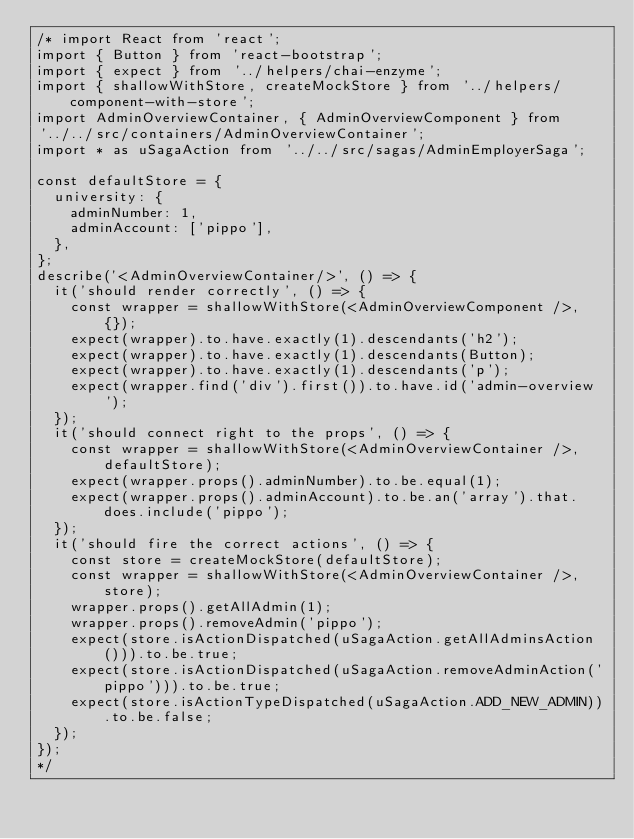Convert code to text. <code><loc_0><loc_0><loc_500><loc_500><_JavaScript_>/* import React from 'react';
import { Button } from 'react-bootstrap';
import { expect } from '../helpers/chai-enzyme';
import { shallowWithStore, createMockStore } from '../helpers/component-with-store';
import AdminOverviewContainer, { AdminOverviewComponent } from
'../../src/containers/AdminOverviewContainer';
import * as uSagaAction from '../../src/sagas/AdminEmployerSaga';

const defaultStore = {
  university: {
    adminNumber: 1,
    adminAccount: ['pippo'],
  },
};
describe('<AdminOverviewContainer/>', () => {
  it('should render correctly', () => {
    const wrapper = shallowWithStore(<AdminOverviewComponent />, {});
    expect(wrapper).to.have.exactly(1).descendants('h2');
    expect(wrapper).to.have.exactly(1).descendants(Button);
    expect(wrapper).to.have.exactly(1).descendants('p');
    expect(wrapper.find('div').first()).to.have.id('admin-overview');
  });
  it('should connect right to the props', () => {
    const wrapper = shallowWithStore(<AdminOverviewContainer />, defaultStore);
    expect(wrapper.props().adminNumber).to.be.equal(1);
    expect(wrapper.props().adminAccount).to.be.an('array').that.does.include('pippo');
  });
  it('should fire the correct actions', () => {
    const store = createMockStore(defaultStore);
    const wrapper = shallowWithStore(<AdminOverviewContainer />, store);
    wrapper.props().getAllAdmin(1);
    wrapper.props().removeAdmin('pippo');
    expect(store.isActionDispatched(uSagaAction.getAllAdminsAction())).to.be.true;
    expect(store.isActionDispatched(uSagaAction.removeAdminAction('pippo'))).to.be.true;
    expect(store.isActionTypeDispatched(uSagaAction.ADD_NEW_ADMIN)).to.be.false;
  });
});
*/
</code> 